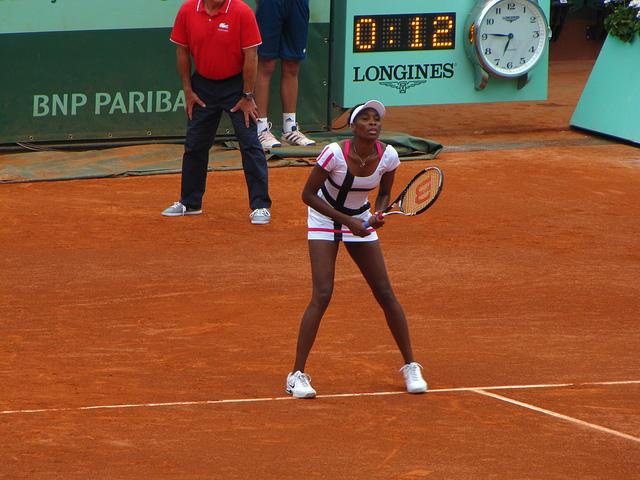Read and extract the text from this image. BNP PARIBA LONGINES 0 1 2 9 7 A 